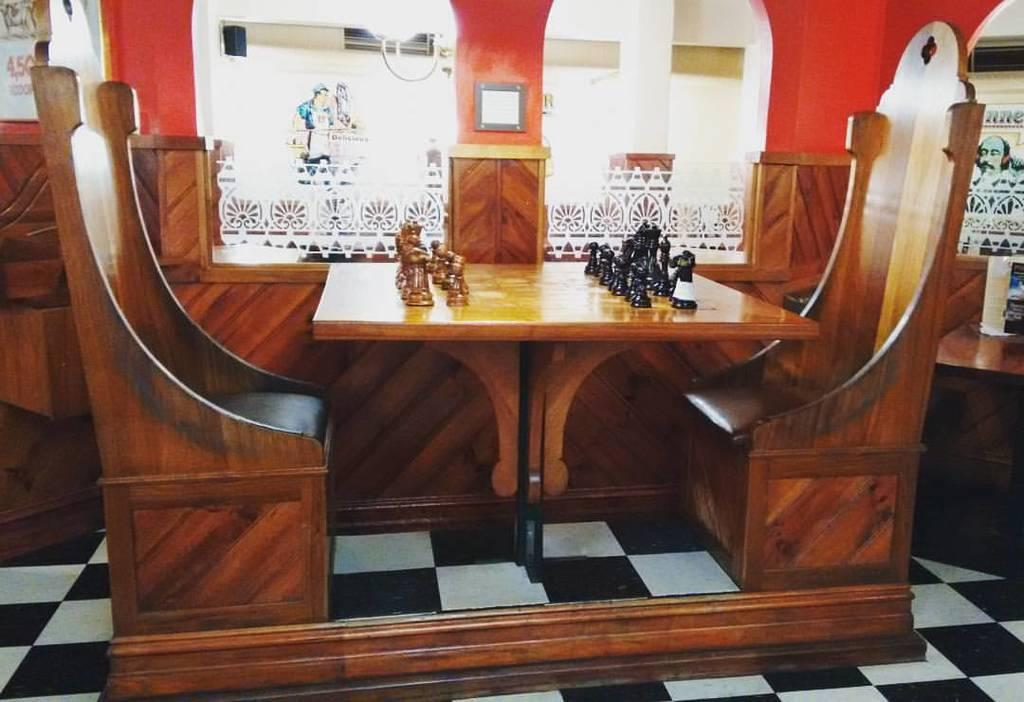What type of furniture is visible in the image? There is a table in the image. What is placed on the table? Chess coins are present on the table. What type of vehicles can be seen in the image? There are cars in the image. What can be observed about the windows in the image? There are glass windows with designs in the image. Is there any source of light visible in the image? There may be a light in the image. How many people are participating in the event depicted in the image? There is no event depicted in the image, so it is not possible to determine the number of participants. What type of wool is used to make the rug in the image? There is no rug present in the image, so it is not possible to determine the type of wool used. 